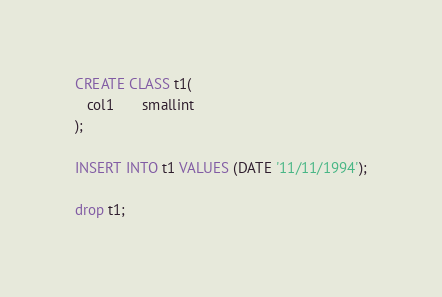<code> <loc_0><loc_0><loc_500><loc_500><_SQL_>

CREATE CLASS t1(
   col1       smallint 
);

INSERT INTO t1 VALUES (DATE '11/11/1994');

drop t1;</code> 